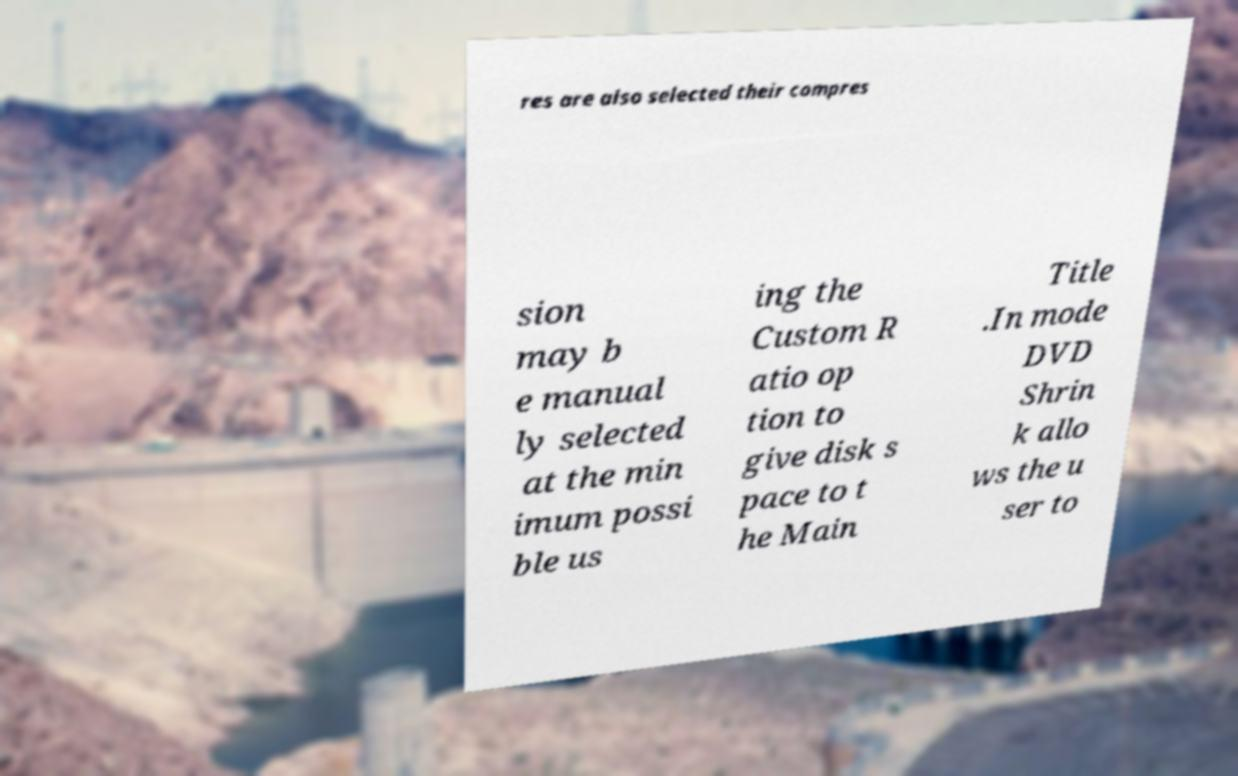Can you accurately transcribe the text from the provided image for me? res are also selected their compres sion may b e manual ly selected at the min imum possi ble us ing the Custom R atio op tion to give disk s pace to t he Main Title .In mode DVD Shrin k allo ws the u ser to 